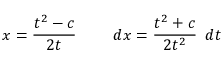<formula> <loc_0><loc_0><loc_500><loc_500>x = { \frac { t ^ { 2 } - c } { 2 t } } \quad \ d x = { \frac { t ^ { 2 } + c } { 2 t ^ { 2 } } } \, \ d t</formula> 